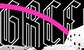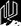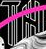Read the text content from these images in order, separated by a semicolon. GRCC; #; TH 